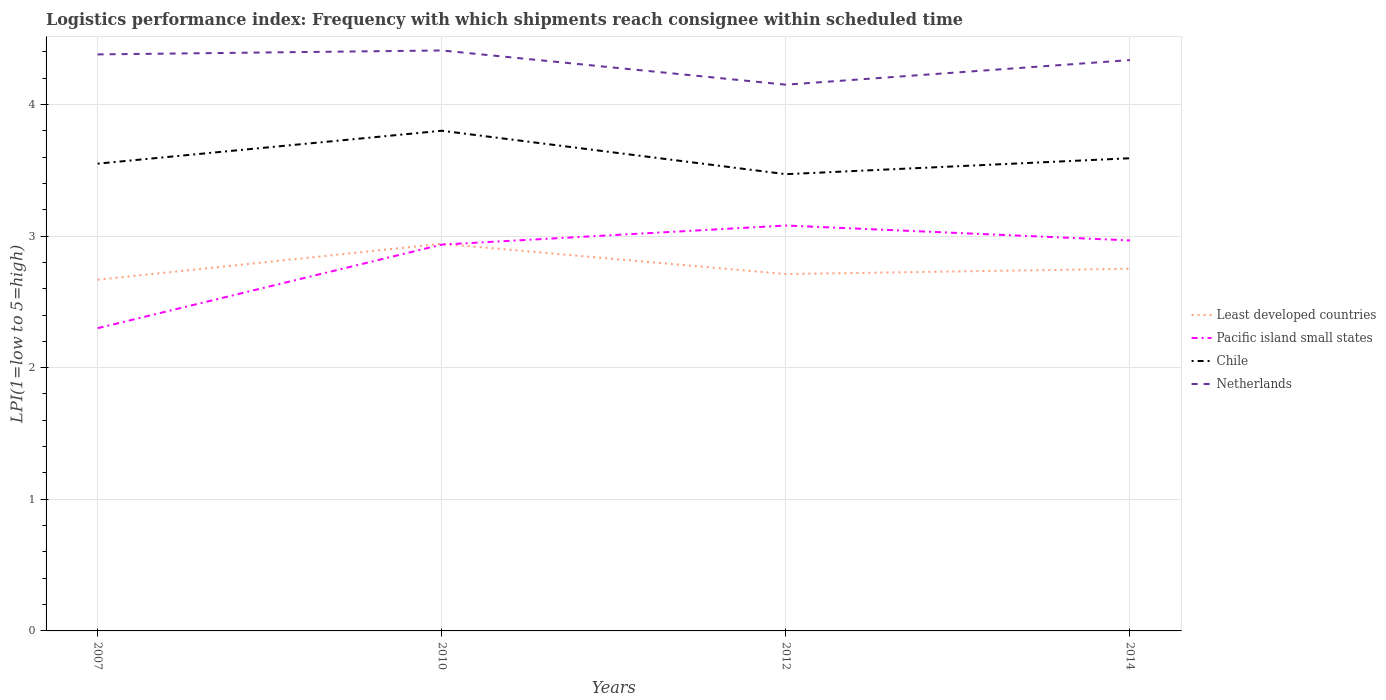Does the line corresponding to Least developed countries intersect with the line corresponding to Netherlands?
Ensure brevity in your answer.  No. Across all years, what is the maximum logistics performance index in Least developed countries?
Offer a terse response. 2.67. In which year was the logistics performance index in Pacific island small states maximum?
Make the answer very short. 2007. What is the total logistics performance index in Pacific island small states in the graph?
Keep it short and to the point. -0.15. What is the difference between the highest and the second highest logistics performance index in Least developed countries?
Offer a very short reply. 0.27. What is the difference between the highest and the lowest logistics performance index in Least developed countries?
Ensure brevity in your answer.  1. Is the logistics performance index in Netherlands strictly greater than the logistics performance index in Chile over the years?
Provide a short and direct response. No. How many lines are there?
Provide a succinct answer. 4. What is the difference between two consecutive major ticks on the Y-axis?
Your response must be concise. 1. Does the graph contain grids?
Offer a very short reply. Yes. Where does the legend appear in the graph?
Your answer should be compact. Center right. What is the title of the graph?
Give a very brief answer. Logistics performance index: Frequency with which shipments reach consignee within scheduled time. What is the label or title of the X-axis?
Provide a succinct answer. Years. What is the label or title of the Y-axis?
Give a very brief answer. LPI(1=low to 5=high). What is the LPI(1=low to 5=high) of Least developed countries in 2007?
Provide a short and direct response. 2.67. What is the LPI(1=low to 5=high) of Pacific island small states in 2007?
Give a very brief answer. 2.3. What is the LPI(1=low to 5=high) of Chile in 2007?
Offer a very short reply. 3.55. What is the LPI(1=low to 5=high) in Netherlands in 2007?
Your answer should be very brief. 4.38. What is the LPI(1=low to 5=high) in Least developed countries in 2010?
Make the answer very short. 2.94. What is the LPI(1=low to 5=high) of Pacific island small states in 2010?
Your response must be concise. 2.94. What is the LPI(1=low to 5=high) of Netherlands in 2010?
Your response must be concise. 4.41. What is the LPI(1=low to 5=high) in Least developed countries in 2012?
Your response must be concise. 2.71. What is the LPI(1=low to 5=high) of Pacific island small states in 2012?
Offer a terse response. 3.08. What is the LPI(1=low to 5=high) of Chile in 2012?
Your response must be concise. 3.47. What is the LPI(1=low to 5=high) of Netherlands in 2012?
Make the answer very short. 4.15. What is the LPI(1=low to 5=high) of Least developed countries in 2014?
Provide a short and direct response. 2.75. What is the LPI(1=low to 5=high) in Pacific island small states in 2014?
Offer a very short reply. 2.97. What is the LPI(1=low to 5=high) of Chile in 2014?
Make the answer very short. 3.59. What is the LPI(1=low to 5=high) in Netherlands in 2014?
Make the answer very short. 4.34. Across all years, what is the maximum LPI(1=low to 5=high) in Least developed countries?
Offer a very short reply. 2.94. Across all years, what is the maximum LPI(1=low to 5=high) in Pacific island small states?
Give a very brief answer. 3.08. Across all years, what is the maximum LPI(1=low to 5=high) in Netherlands?
Give a very brief answer. 4.41. Across all years, what is the minimum LPI(1=low to 5=high) of Least developed countries?
Offer a terse response. 2.67. Across all years, what is the minimum LPI(1=low to 5=high) of Chile?
Offer a very short reply. 3.47. Across all years, what is the minimum LPI(1=low to 5=high) of Netherlands?
Give a very brief answer. 4.15. What is the total LPI(1=low to 5=high) of Least developed countries in the graph?
Offer a very short reply. 11.07. What is the total LPI(1=low to 5=high) in Pacific island small states in the graph?
Offer a terse response. 11.28. What is the total LPI(1=low to 5=high) of Chile in the graph?
Give a very brief answer. 14.41. What is the total LPI(1=low to 5=high) of Netherlands in the graph?
Provide a short and direct response. 17.28. What is the difference between the LPI(1=low to 5=high) in Least developed countries in 2007 and that in 2010?
Ensure brevity in your answer.  -0.27. What is the difference between the LPI(1=low to 5=high) of Pacific island small states in 2007 and that in 2010?
Offer a very short reply. -0.64. What is the difference between the LPI(1=low to 5=high) in Netherlands in 2007 and that in 2010?
Ensure brevity in your answer.  -0.03. What is the difference between the LPI(1=low to 5=high) of Least developed countries in 2007 and that in 2012?
Provide a short and direct response. -0.04. What is the difference between the LPI(1=low to 5=high) in Pacific island small states in 2007 and that in 2012?
Offer a terse response. -0.78. What is the difference between the LPI(1=low to 5=high) in Chile in 2007 and that in 2012?
Make the answer very short. 0.08. What is the difference between the LPI(1=low to 5=high) in Netherlands in 2007 and that in 2012?
Keep it short and to the point. 0.23. What is the difference between the LPI(1=low to 5=high) in Least developed countries in 2007 and that in 2014?
Give a very brief answer. -0.08. What is the difference between the LPI(1=low to 5=high) in Pacific island small states in 2007 and that in 2014?
Offer a terse response. -0.67. What is the difference between the LPI(1=low to 5=high) of Chile in 2007 and that in 2014?
Offer a very short reply. -0.04. What is the difference between the LPI(1=low to 5=high) of Netherlands in 2007 and that in 2014?
Your response must be concise. 0.04. What is the difference between the LPI(1=low to 5=high) in Least developed countries in 2010 and that in 2012?
Your answer should be compact. 0.23. What is the difference between the LPI(1=low to 5=high) of Pacific island small states in 2010 and that in 2012?
Make the answer very short. -0.14. What is the difference between the LPI(1=low to 5=high) of Chile in 2010 and that in 2012?
Provide a succinct answer. 0.33. What is the difference between the LPI(1=low to 5=high) of Netherlands in 2010 and that in 2012?
Your answer should be compact. 0.26. What is the difference between the LPI(1=low to 5=high) of Least developed countries in 2010 and that in 2014?
Keep it short and to the point. 0.19. What is the difference between the LPI(1=low to 5=high) in Pacific island small states in 2010 and that in 2014?
Your response must be concise. -0.03. What is the difference between the LPI(1=low to 5=high) of Chile in 2010 and that in 2014?
Offer a terse response. 0.21. What is the difference between the LPI(1=low to 5=high) of Netherlands in 2010 and that in 2014?
Provide a short and direct response. 0.07. What is the difference between the LPI(1=low to 5=high) of Least developed countries in 2012 and that in 2014?
Your answer should be compact. -0.04. What is the difference between the LPI(1=low to 5=high) in Pacific island small states in 2012 and that in 2014?
Your response must be concise. 0.11. What is the difference between the LPI(1=low to 5=high) of Chile in 2012 and that in 2014?
Keep it short and to the point. -0.12. What is the difference between the LPI(1=low to 5=high) of Netherlands in 2012 and that in 2014?
Provide a short and direct response. -0.19. What is the difference between the LPI(1=low to 5=high) of Least developed countries in 2007 and the LPI(1=low to 5=high) of Pacific island small states in 2010?
Provide a succinct answer. -0.27. What is the difference between the LPI(1=low to 5=high) in Least developed countries in 2007 and the LPI(1=low to 5=high) in Chile in 2010?
Provide a short and direct response. -1.13. What is the difference between the LPI(1=low to 5=high) in Least developed countries in 2007 and the LPI(1=low to 5=high) in Netherlands in 2010?
Your answer should be very brief. -1.74. What is the difference between the LPI(1=low to 5=high) in Pacific island small states in 2007 and the LPI(1=low to 5=high) in Netherlands in 2010?
Keep it short and to the point. -2.11. What is the difference between the LPI(1=low to 5=high) in Chile in 2007 and the LPI(1=low to 5=high) in Netherlands in 2010?
Your answer should be very brief. -0.86. What is the difference between the LPI(1=low to 5=high) of Least developed countries in 2007 and the LPI(1=low to 5=high) of Pacific island small states in 2012?
Keep it short and to the point. -0.41. What is the difference between the LPI(1=low to 5=high) of Least developed countries in 2007 and the LPI(1=low to 5=high) of Chile in 2012?
Provide a succinct answer. -0.8. What is the difference between the LPI(1=low to 5=high) in Least developed countries in 2007 and the LPI(1=low to 5=high) in Netherlands in 2012?
Keep it short and to the point. -1.48. What is the difference between the LPI(1=low to 5=high) of Pacific island small states in 2007 and the LPI(1=low to 5=high) of Chile in 2012?
Ensure brevity in your answer.  -1.17. What is the difference between the LPI(1=low to 5=high) in Pacific island small states in 2007 and the LPI(1=low to 5=high) in Netherlands in 2012?
Ensure brevity in your answer.  -1.85. What is the difference between the LPI(1=low to 5=high) in Chile in 2007 and the LPI(1=low to 5=high) in Netherlands in 2012?
Your response must be concise. -0.6. What is the difference between the LPI(1=low to 5=high) in Least developed countries in 2007 and the LPI(1=low to 5=high) in Pacific island small states in 2014?
Your response must be concise. -0.3. What is the difference between the LPI(1=low to 5=high) in Least developed countries in 2007 and the LPI(1=low to 5=high) in Chile in 2014?
Your response must be concise. -0.92. What is the difference between the LPI(1=low to 5=high) of Least developed countries in 2007 and the LPI(1=low to 5=high) of Netherlands in 2014?
Offer a terse response. -1.67. What is the difference between the LPI(1=low to 5=high) in Pacific island small states in 2007 and the LPI(1=low to 5=high) in Chile in 2014?
Your response must be concise. -1.29. What is the difference between the LPI(1=low to 5=high) in Pacific island small states in 2007 and the LPI(1=low to 5=high) in Netherlands in 2014?
Provide a short and direct response. -2.04. What is the difference between the LPI(1=low to 5=high) in Chile in 2007 and the LPI(1=low to 5=high) in Netherlands in 2014?
Make the answer very short. -0.79. What is the difference between the LPI(1=low to 5=high) of Least developed countries in 2010 and the LPI(1=low to 5=high) of Pacific island small states in 2012?
Your response must be concise. -0.14. What is the difference between the LPI(1=low to 5=high) of Least developed countries in 2010 and the LPI(1=low to 5=high) of Chile in 2012?
Provide a short and direct response. -0.53. What is the difference between the LPI(1=low to 5=high) of Least developed countries in 2010 and the LPI(1=low to 5=high) of Netherlands in 2012?
Offer a terse response. -1.21. What is the difference between the LPI(1=low to 5=high) in Pacific island small states in 2010 and the LPI(1=low to 5=high) in Chile in 2012?
Your response must be concise. -0.54. What is the difference between the LPI(1=low to 5=high) of Pacific island small states in 2010 and the LPI(1=low to 5=high) of Netherlands in 2012?
Ensure brevity in your answer.  -1.22. What is the difference between the LPI(1=low to 5=high) of Chile in 2010 and the LPI(1=low to 5=high) of Netherlands in 2012?
Give a very brief answer. -0.35. What is the difference between the LPI(1=low to 5=high) of Least developed countries in 2010 and the LPI(1=low to 5=high) of Pacific island small states in 2014?
Provide a succinct answer. -0.03. What is the difference between the LPI(1=low to 5=high) of Least developed countries in 2010 and the LPI(1=low to 5=high) of Chile in 2014?
Offer a very short reply. -0.65. What is the difference between the LPI(1=low to 5=high) of Least developed countries in 2010 and the LPI(1=low to 5=high) of Netherlands in 2014?
Provide a short and direct response. -1.4. What is the difference between the LPI(1=low to 5=high) in Pacific island small states in 2010 and the LPI(1=low to 5=high) in Chile in 2014?
Your response must be concise. -0.66. What is the difference between the LPI(1=low to 5=high) of Pacific island small states in 2010 and the LPI(1=low to 5=high) of Netherlands in 2014?
Make the answer very short. -1.4. What is the difference between the LPI(1=low to 5=high) of Chile in 2010 and the LPI(1=low to 5=high) of Netherlands in 2014?
Offer a very short reply. -0.54. What is the difference between the LPI(1=low to 5=high) of Least developed countries in 2012 and the LPI(1=low to 5=high) of Pacific island small states in 2014?
Offer a terse response. -0.26. What is the difference between the LPI(1=low to 5=high) of Least developed countries in 2012 and the LPI(1=low to 5=high) of Chile in 2014?
Your response must be concise. -0.88. What is the difference between the LPI(1=low to 5=high) in Least developed countries in 2012 and the LPI(1=low to 5=high) in Netherlands in 2014?
Offer a terse response. -1.63. What is the difference between the LPI(1=low to 5=high) of Pacific island small states in 2012 and the LPI(1=low to 5=high) of Chile in 2014?
Make the answer very short. -0.51. What is the difference between the LPI(1=low to 5=high) of Pacific island small states in 2012 and the LPI(1=low to 5=high) of Netherlands in 2014?
Give a very brief answer. -1.26. What is the difference between the LPI(1=low to 5=high) of Chile in 2012 and the LPI(1=low to 5=high) of Netherlands in 2014?
Keep it short and to the point. -0.87. What is the average LPI(1=low to 5=high) in Least developed countries per year?
Your response must be concise. 2.77. What is the average LPI(1=low to 5=high) of Pacific island small states per year?
Provide a short and direct response. 2.82. What is the average LPI(1=low to 5=high) in Chile per year?
Your response must be concise. 3.6. What is the average LPI(1=low to 5=high) in Netherlands per year?
Give a very brief answer. 4.32. In the year 2007, what is the difference between the LPI(1=low to 5=high) in Least developed countries and LPI(1=low to 5=high) in Pacific island small states?
Offer a terse response. 0.37. In the year 2007, what is the difference between the LPI(1=low to 5=high) of Least developed countries and LPI(1=low to 5=high) of Chile?
Your response must be concise. -0.88. In the year 2007, what is the difference between the LPI(1=low to 5=high) of Least developed countries and LPI(1=low to 5=high) of Netherlands?
Make the answer very short. -1.71. In the year 2007, what is the difference between the LPI(1=low to 5=high) of Pacific island small states and LPI(1=low to 5=high) of Chile?
Give a very brief answer. -1.25. In the year 2007, what is the difference between the LPI(1=low to 5=high) in Pacific island small states and LPI(1=low to 5=high) in Netherlands?
Your answer should be compact. -2.08. In the year 2007, what is the difference between the LPI(1=low to 5=high) in Chile and LPI(1=low to 5=high) in Netherlands?
Provide a succinct answer. -0.83. In the year 2010, what is the difference between the LPI(1=low to 5=high) in Least developed countries and LPI(1=low to 5=high) in Pacific island small states?
Keep it short and to the point. 0.01. In the year 2010, what is the difference between the LPI(1=low to 5=high) of Least developed countries and LPI(1=low to 5=high) of Chile?
Your answer should be compact. -0.86. In the year 2010, what is the difference between the LPI(1=low to 5=high) of Least developed countries and LPI(1=low to 5=high) of Netherlands?
Your response must be concise. -1.47. In the year 2010, what is the difference between the LPI(1=low to 5=high) of Pacific island small states and LPI(1=low to 5=high) of Chile?
Provide a short and direct response. -0.86. In the year 2010, what is the difference between the LPI(1=low to 5=high) of Pacific island small states and LPI(1=low to 5=high) of Netherlands?
Your response must be concise. -1.48. In the year 2010, what is the difference between the LPI(1=low to 5=high) of Chile and LPI(1=low to 5=high) of Netherlands?
Your answer should be compact. -0.61. In the year 2012, what is the difference between the LPI(1=low to 5=high) of Least developed countries and LPI(1=low to 5=high) of Pacific island small states?
Your response must be concise. -0.37. In the year 2012, what is the difference between the LPI(1=low to 5=high) of Least developed countries and LPI(1=low to 5=high) of Chile?
Provide a succinct answer. -0.76. In the year 2012, what is the difference between the LPI(1=low to 5=high) in Least developed countries and LPI(1=low to 5=high) in Netherlands?
Provide a short and direct response. -1.44. In the year 2012, what is the difference between the LPI(1=low to 5=high) in Pacific island small states and LPI(1=low to 5=high) in Chile?
Offer a very short reply. -0.39. In the year 2012, what is the difference between the LPI(1=low to 5=high) in Pacific island small states and LPI(1=low to 5=high) in Netherlands?
Offer a very short reply. -1.07. In the year 2012, what is the difference between the LPI(1=low to 5=high) of Chile and LPI(1=low to 5=high) of Netherlands?
Keep it short and to the point. -0.68. In the year 2014, what is the difference between the LPI(1=low to 5=high) of Least developed countries and LPI(1=low to 5=high) of Pacific island small states?
Provide a succinct answer. -0.22. In the year 2014, what is the difference between the LPI(1=low to 5=high) of Least developed countries and LPI(1=low to 5=high) of Chile?
Provide a short and direct response. -0.84. In the year 2014, what is the difference between the LPI(1=low to 5=high) of Least developed countries and LPI(1=low to 5=high) of Netherlands?
Your answer should be compact. -1.59. In the year 2014, what is the difference between the LPI(1=low to 5=high) in Pacific island small states and LPI(1=low to 5=high) in Chile?
Your response must be concise. -0.62. In the year 2014, what is the difference between the LPI(1=low to 5=high) of Pacific island small states and LPI(1=low to 5=high) of Netherlands?
Offer a terse response. -1.37. In the year 2014, what is the difference between the LPI(1=low to 5=high) in Chile and LPI(1=low to 5=high) in Netherlands?
Your response must be concise. -0.75. What is the ratio of the LPI(1=low to 5=high) of Least developed countries in 2007 to that in 2010?
Your response must be concise. 0.91. What is the ratio of the LPI(1=low to 5=high) of Pacific island small states in 2007 to that in 2010?
Make the answer very short. 0.78. What is the ratio of the LPI(1=low to 5=high) in Chile in 2007 to that in 2010?
Ensure brevity in your answer.  0.93. What is the ratio of the LPI(1=low to 5=high) in Netherlands in 2007 to that in 2010?
Provide a short and direct response. 0.99. What is the ratio of the LPI(1=low to 5=high) of Least developed countries in 2007 to that in 2012?
Provide a short and direct response. 0.98. What is the ratio of the LPI(1=low to 5=high) in Pacific island small states in 2007 to that in 2012?
Ensure brevity in your answer.  0.75. What is the ratio of the LPI(1=low to 5=high) of Chile in 2007 to that in 2012?
Provide a short and direct response. 1.02. What is the ratio of the LPI(1=low to 5=high) in Netherlands in 2007 to that in 2012?
Offer a terse response. 1.06. What is the ratio of the LPI(1=low to 5=high) of Least developed countries in 2007 to that in 2014?
Offer a terse response. 0.97. What is the ratio of the LPI(1=low to 5=high) in Pacific island small states in 2007 to that in 2014?
Provide a succinct answer. 0.78. What is the ratio of the LPI(1=low to 5=high) in Chile in 2007 to that in 2014?
Offer a very short reply. 0.99. What is the ratio of the LPI(1=low to 5=high) in Netherlands in 2007 to that in 2014?
Provide a short and direct response. 1.01. What is the ratio of the LPI(1=low to 5=high) of Least developed countries in 2010 to that in 2012?
Offer a terse response. 1.08. What is the ratio of the LPI(1=low to 5=high) in Pacific island small states in 2010 to that in 2012?
Offer a very short reply. 0.95. What is the ratio of the LPI(1=low to 5=high) of Chile in 2010 to that in 2012?
Offer a terse response. 1.1. What is the ratio of the LPI(1=low to 5=high) of Netherlands in 2010 to that in 2012?
Your answer should be compact. 1.06. What is the ratio of the LPI(1=low to 5=high) of Least developed countries in 2010 to that in 2014?
Your response must be concise. 1.07. What is the ratio of the LPI(1=low to 5=high) of Pacific island small states in 2010 to that in 2014?
Your answer should be very brief. 0.99. What is the ratio of the LPI(1=low to 5=high) of Chile in 2010 to that in 2014?
Offer a terse response. 1.06. What is the ratio of the LPI(1=low to 5=high) of Netherlands in 2010 to that in 2014?
Your answer should be compact. 1.02. What is the ratio of the LPI(1=low to 5=high) in Least developed countries in 2012 to that in 2014?
Ensure brevity in your answer.  0.99. What is the ratio of the LPI(1=low to 5=high) in Pacific island small states in 2012 to that in 2014?
Your answer should be compact. 1.04. What is the ratio of the LPI(1=low to 5=high) of Chile in 2012 to that in 2014?
Make the answer very short. 0.97. What is the ratio of the LPI(1=low to 5=high) of Netherlands in 2012 to that in 2014?
Make the answer very short. 0.96. What is the difference between the highest and the second highest LPI(1=low to 5=high) of Least developed countries?
Your answer should be very brief. 0.19. What is the difference between the highest and the second highest LPI(1=low to 5=high) in Pacific island small states?
Give a very brief answer. 0.11. What is the difference between the highest and the second highest LPI(1=low to 5=high) of Chile?
Your answer should be compact. 0.21. What is the difference between the highest and the second highest LPI(1=low to 5=high) of Netherlands?
Offer a very short reply. 0.03. What is the difference between the highest and the lowest LPI(1=low to 5=high) of Least developed countries?
Make the answer very short. 0.27. What is the difference between the highest and the lowest LPI(1=low to 5=high) in Pacific island small states?
Provide a succinct answer. 0.78. What is the difference between the highest and the lowest LPI(1=low to 5=high) of Chile?
Keep it short and to the point. 0.33. What is the difference between the highest and the lowest LPI(1=low to 5=high) in Netherlands?
Provide a succinct answer. 0.26. 